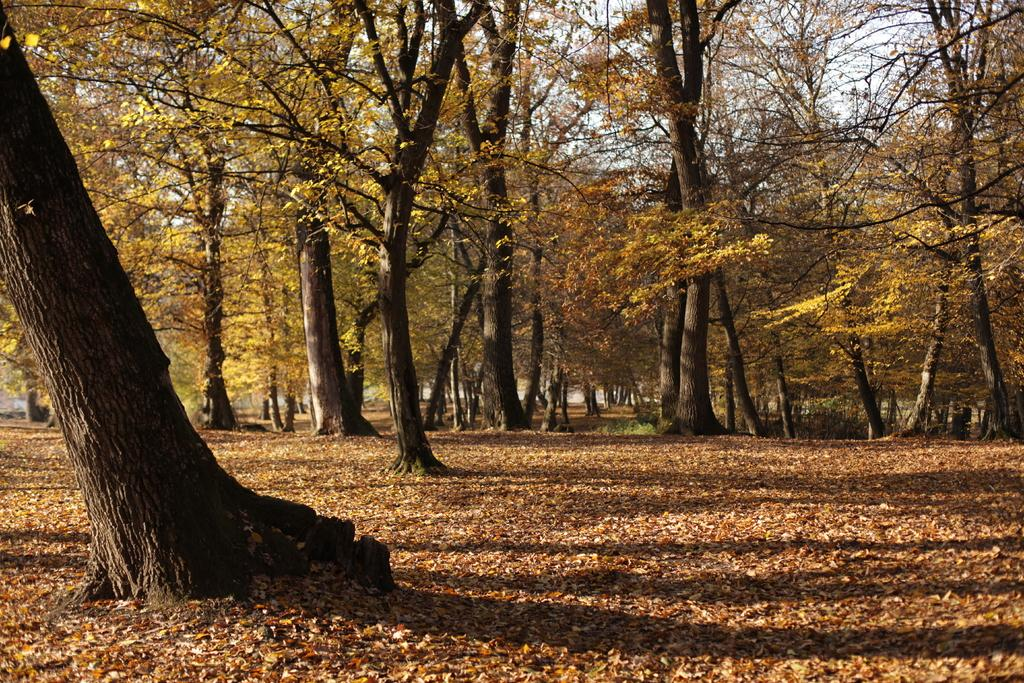What is on the ground in the image? There are dried leaves on the ground in the image. What type of vegetation is present in the image? There are trees in the image. What is visible at the top of the image? The sky is visible at the top of the image. Where is the plastic patch located in the image? There is no plastic patch present in the image. What type of railway can be seen in the image? There is no railway present in the image. 